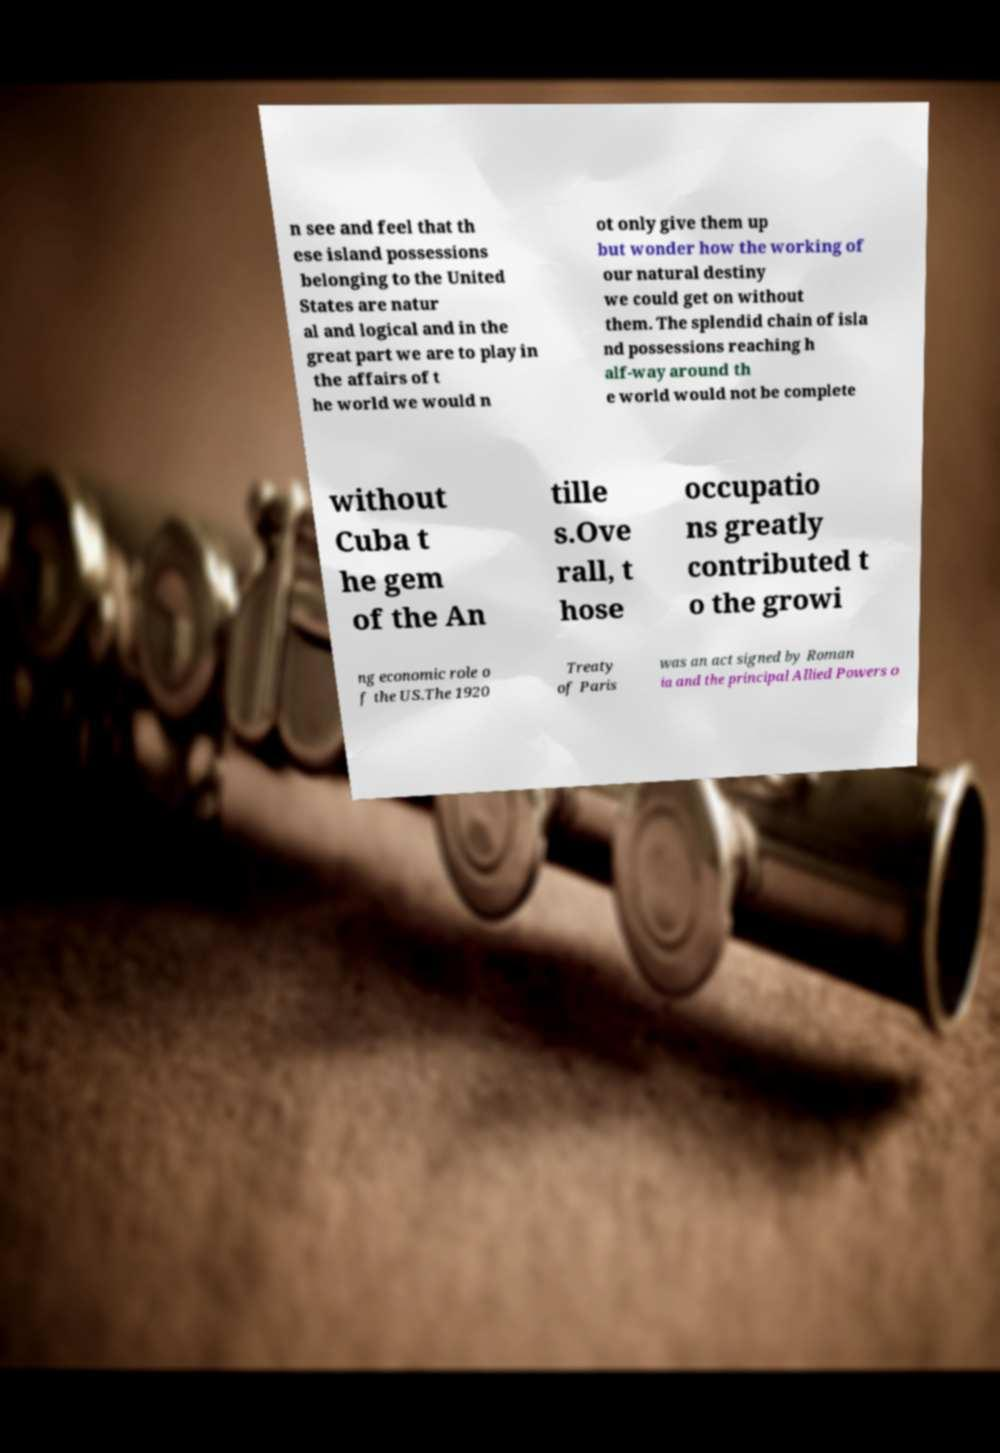What messages or text are displayed in this image? I need them in a readable, typed format. n see and feel that th ese island possessions belonging to the United States are natur al and logical and in the great part we are to play in the affairs of t he world we would n ot only give them up but wonder how the working of our natural destiny we could get on without them. The splendid chain of isla nd possessions reaching h alf-way around th e world would not be complete without Cuba t he gem of the An tille s.Ove rall, t hose occupatio ns greatly contributed t o the growi ng economic role o f the US.The 1920 Treaty of Paris was an act signed by Roman ia and the principal Allied Powers o 